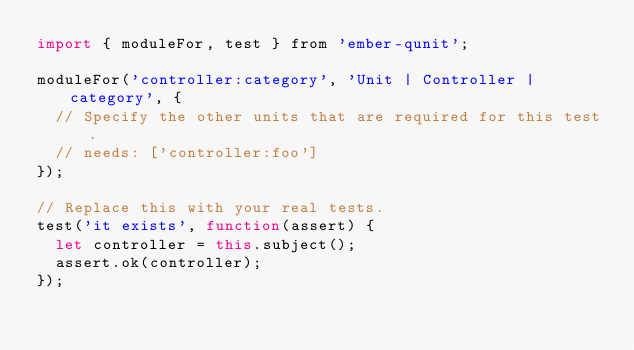<code> <loc_0><loc_0><loc_500><loc_500><_JavaScript_>import { moduleFor, test } from 'ember-qunit';

moduleFor('controller:category', 'Unit | Controller | category', {
  // Specify the other units that are required for this test.
  // needs: ['controller:foo']
});

// Replace this with your real tests.
test('it exists', function(assert) {
  let controller = this.subject();
  assert.ok(controller);
});
</code> 